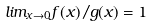<formula> <loc_0><loc_0><loc_500><loc_500>l i m _ { x \rightarrow 0 } f ( x ) / g ( x ) = 1</formula> 